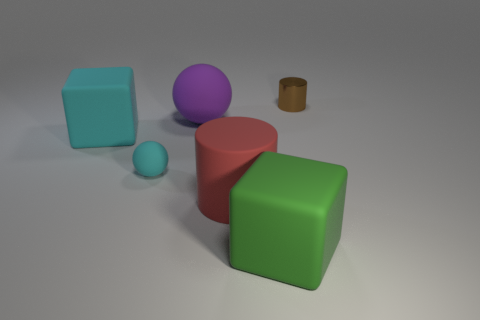Subtract all cubes. How many objects are left? 4 Add 2 cyan matte cubes. How many objects exist? 8 Add 1 large rubber balls. How many large rubber balls are left? 2 Add 3 blue metallic cubes. How many blue metallic cubes exist? 3 Subtract 1 brown cylinders. How many objects are left? 5 Subtract all big red matte blocks. Subtract all large green things. How many objects are left? 5 